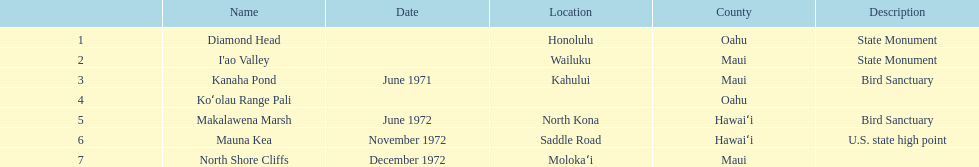Which is the sole name mentioned without a corresponding location? Koʻolau Range Pali. 